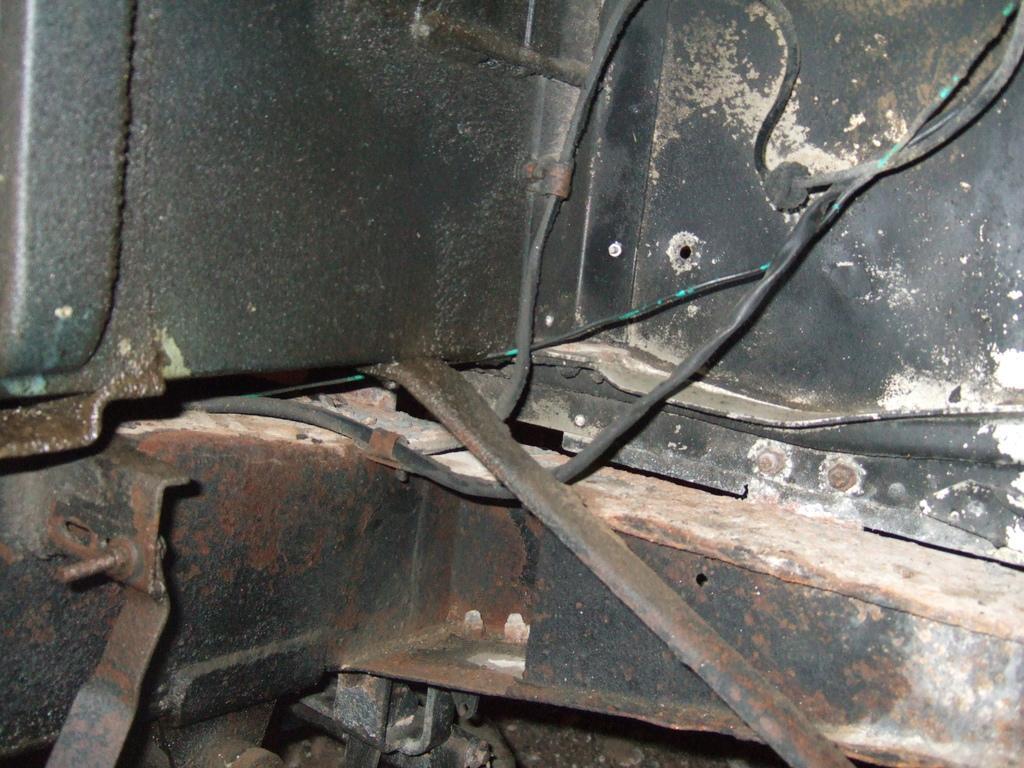Please provide a concise description of this image. In this image we can see a metal object with some wires attached to it. 